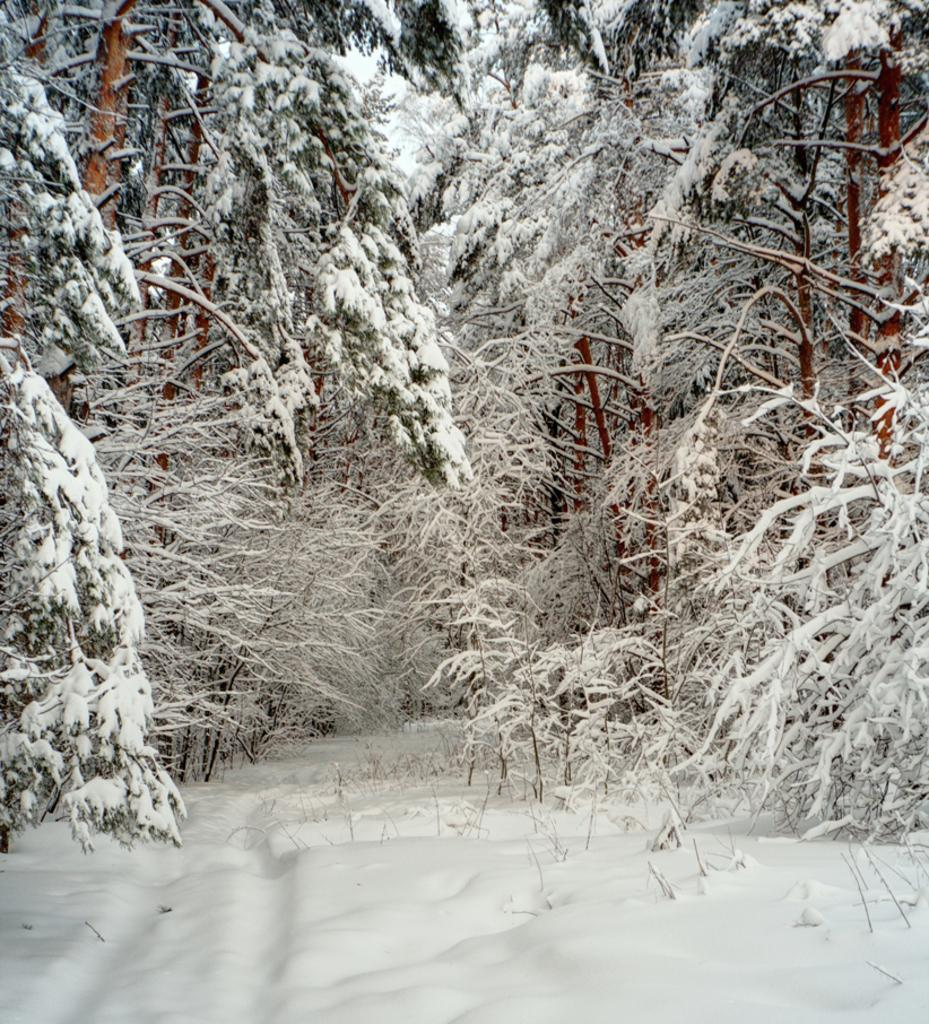What type of vegetation can be seen in the picture? There are trees in the picture. What is covering the trees in the picture? There is snow on the trees. What is visible at the bottom of the picture? There is snow visible at the bottom of the picture. What industry is depicted in the picture? There is no industry present in the picture; it features trees covered in snow. How does the snow stop the trees from growing in the picture? The snow does not stop the trees from growing in the picture; it is simply covering the trees. 